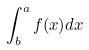Convert formula to latex. <formula><loc_0><loc_0><loc_500><loc_500>\int _ { b } ^ { a } f ( x ) d x</formula> 